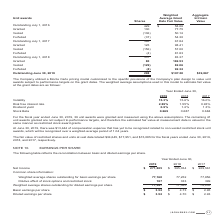According to Jack Henry Associates's financial document, What does the table show? the reconciliation between basic and diluted earnings per share. The document states: "The following table reflects the reconciliation between basic and diluted earnings per share...." Also, Which financial years' information is shown in the table? The document contains multiple relevant values: 2017, 2018, 2019. From the document: "2019 2018 2017 2019 2018 2017 2019 2018 2017..." Also, What is the net income as at June 30, 2019? According to the financial document, $271,885. The relevant text states: "Net Income $ 271,885 $ 365,034 $ 229,561..." Also, can you calculate: What is the average net income for 2018 and 2019? To answer this question, I need to perform calculations using the financial data. The calculation is: (271,885+365,034)/2, which equals 318459.5. This is based on the information: "Net Income $ 271,885 $ 365,034 $ 229,561 Net Income $ 271,885 $ 365,034 $ 229,561..." The key data points involved are: 271,885, 365,034. Also, can you calculate: What is the average basic earnings per share for 2018 and 2019? To answer this question, I need to perform calculations using the financial data. The calculation is: (3.52+4.73)/2, which equals 4.12. This is based on the information: "Basic earnings per share $ 3.52 $ 4.73 $ 2.95 Basic earnings per share $ 3.52 $ 4.73 $ 2.95..." The key data points involved are: 3.52, 4.73. Also, can you calculate: What is the average basic earnings per share for 2017 and 2018? To answer this question, I need to perform calculations using the financial data. The calculation is: (4.73+2.95)/2, which equals 3.84. This is based on the information: "Basic earnings per share $ 3.52 $ 4.73 $ 2.95 Basic earnings per share $ 3.52 $ 4.73 $ 2.95..." The key data points involved are: 2.95, 4.73. 